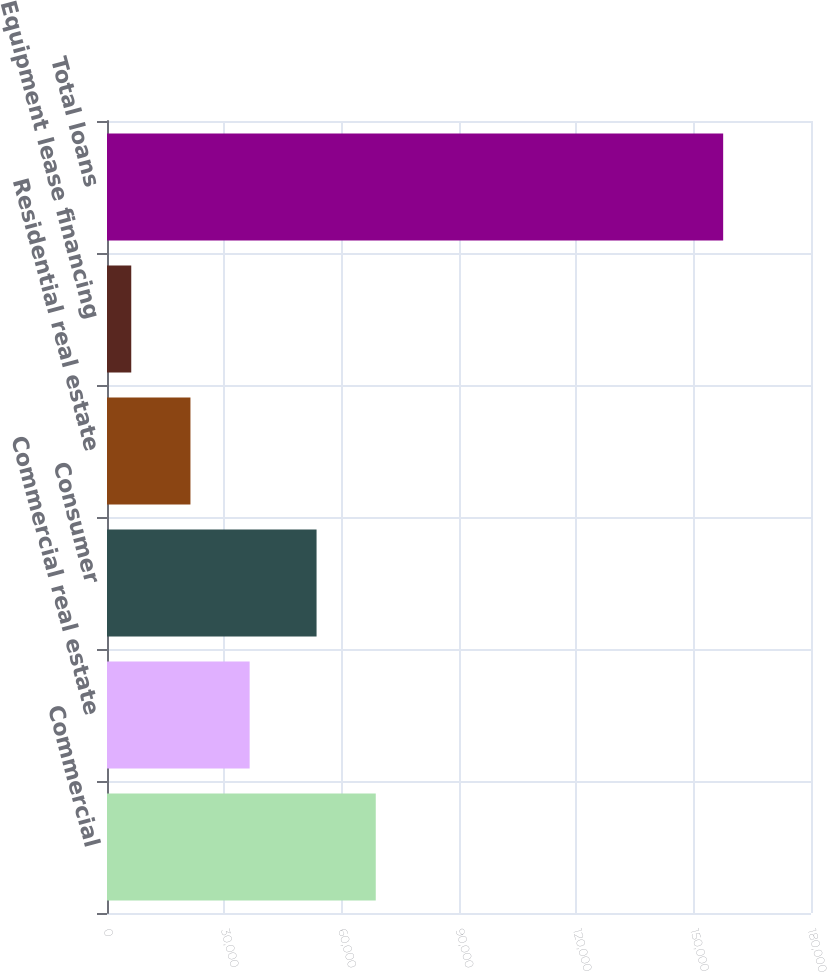Convert chart. <chart><loc_0><loc_0><loc_500><loc_500><bar_chart><fcel>Commercial<fcel>Commercial real estate<fcel>Consumer<fcel>Residential real estate<fcel>Equipment lease financing<fcel>Total loans<nl><fcel>68716.1<fcel>36470.2<fcel>53582<fcel>21336.1<fcel>6202<fcel>157543<nl></chart> 